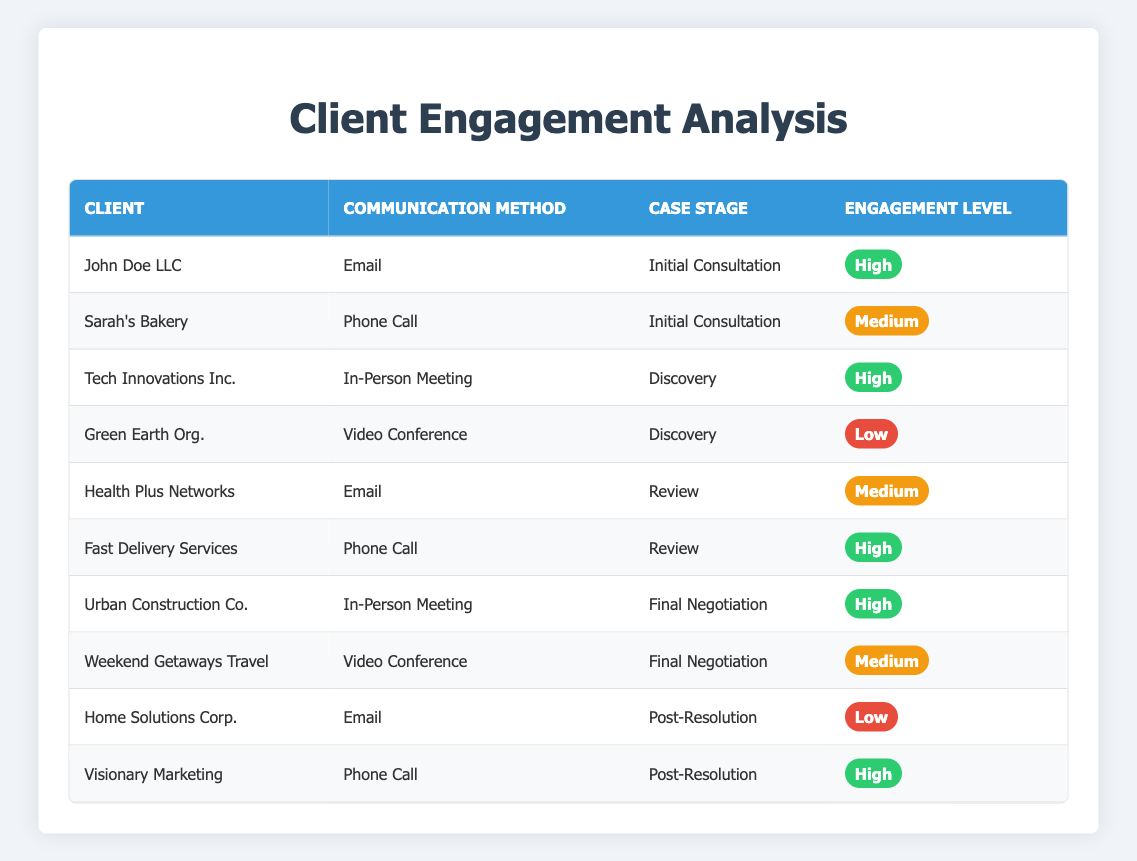What is the engagement level of John Doe LLC? The table shows that John Doe LLC has an engagement level of "High" under the communication method of Email for the case stage of Initial Consultation.
Answer: High How many clients engaged through Video Conference had a "Low" engagement level? According to the table, there are two clients who used Video Conference: Green Earth Org. (Low) and Weekend Getaways Travel (Medium). Thus, only Green Earth Org. has a "Low" engagement level.
Answer: 1 Which communication method has the highest number of clients with a "High" engagement level? Reviewing the table, Email has 1 client (John Doe LLC), Phone Call has 2 clients (Fast Delivery Services and Visionary Marketing), In-Person Meeting has 2 clients (Tech Innovations Inc. and Urban Construction Co.), and Video Conference has 0 clients. Therefore, In-Person Meeting and Phone Call both have the highest number of clients with "High" engagement, with 2 each.
Answer: Phone Call and In-Person Meeting Which client had the lowest engagement level and what was the communication method used? The table shows that Home Solutions Corp. had the lowest engagement level of "Low" and used Email as their communication method.
Answer: Home Solutions Corp. and Email Are there more clients using Email or Phone Call for communication? Based on the table, there are 4 clients who used Email (John Doe LLC, Health Plus Networks, Home Solutions Corp.) and 3 clients who used Phone Call (Sarah's Bakery, Fast Delivery Services, Visionary Marketing). Therefore, there are more clients using Email.
Answer: Email What is the engagement level of Tech Innovations Inc. and how did they communicate? The table indicates that Tech Innovations Inc. engaged through In-Person Meeting and had a "High" engagement level during the Discovery case stage.
Answer: High and In-Person Meeting 